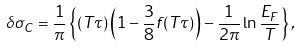<formula> <loc_0><loc_0><loc_500><loc_500>\delta \sigma _ { C } = \frac { 1 } { \pi } \left \{ ( T \tau ) \left ( 1 - \frac { 3 } { 8 } f ( T \tau ) \right ) - \frac { 1 } { 2 \pi } \ln \frac { E _ { F } } { T } \right \} ,</formula> 